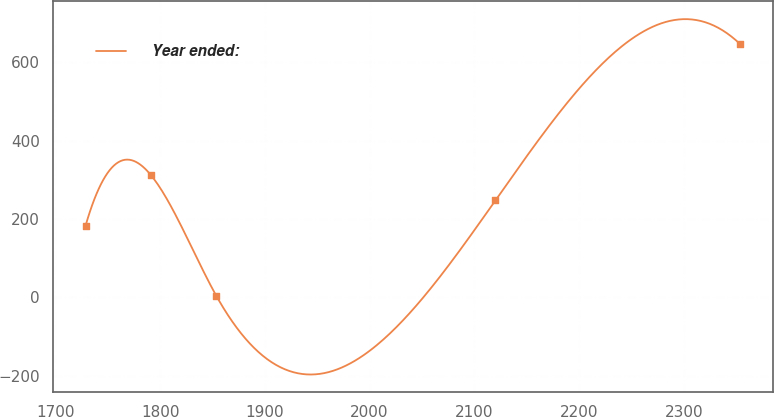<chart> <loc_0><loc_0><loc_500><loc_500><line_chart><ecel><fcel>Year ended:<nl><fcel>1728.86<fcel>183.38<nl><fcel>1791.34<fcel>312.04<nl><fcel>1853.82<fcel>3.47<nl><fcel>2120.07<fcel>247.71<nl><fcel>2353.67<fcel>646.81<nl></chart> 